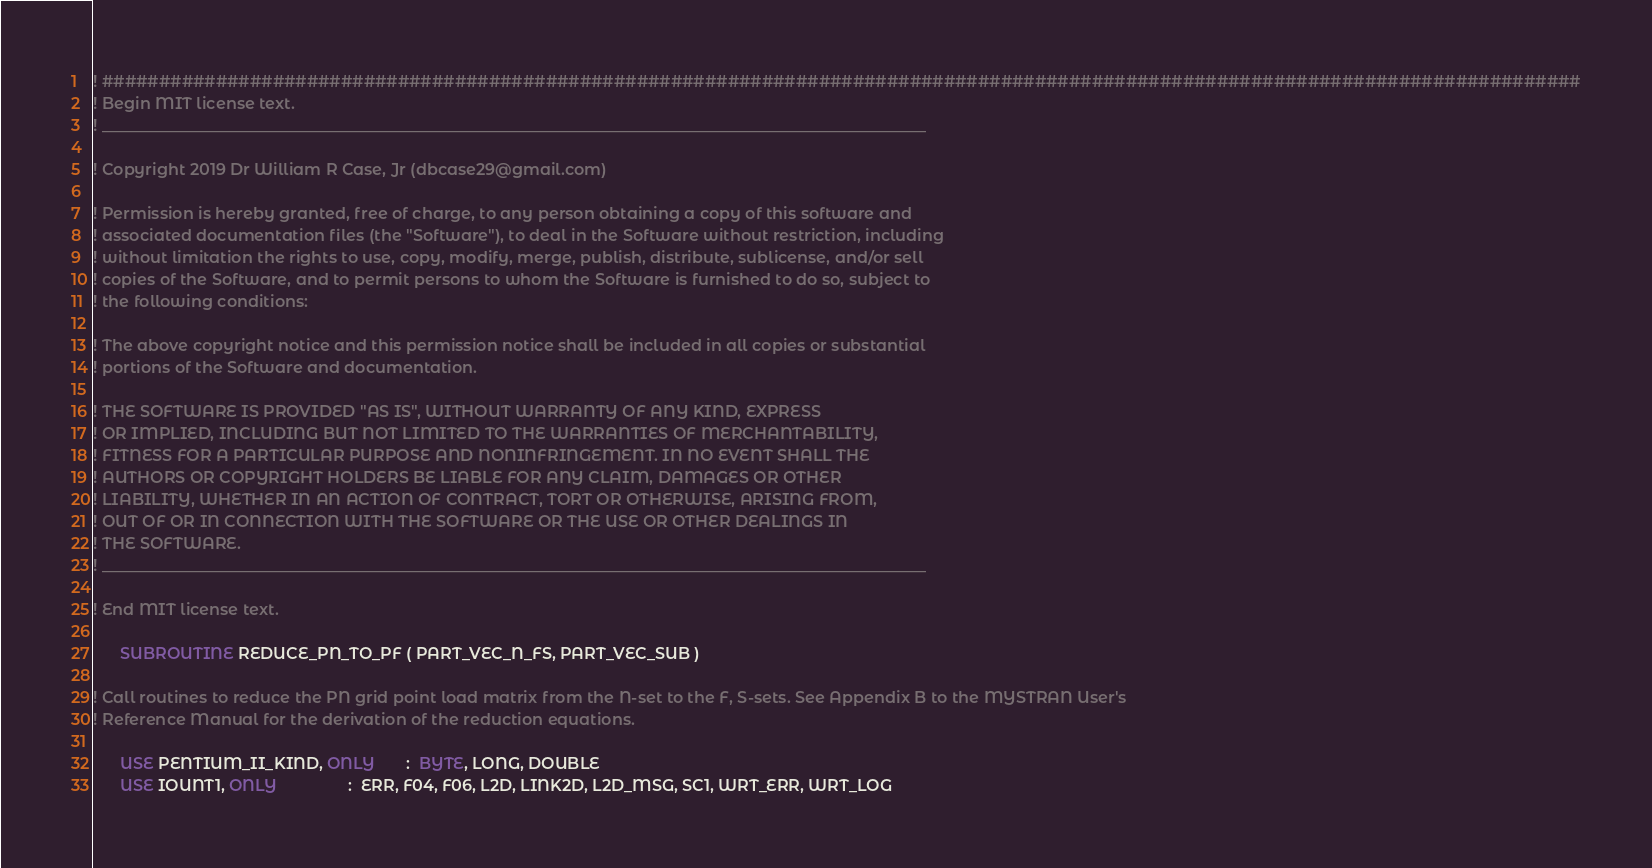Convert code to text. <code><loc_0><loc_0><loc_500><loc_500><_FORTRAN_>! ##################################################################################################################################
! Begin MIT license text.                                                                                    
! _______________________________________________________________________________________________________
                                                                                                         
! Copyright 2019 Dr William R Case, Jr (dbcase29@gmail.com)                                              
                                                                                                         
! Permission is hereby granted, free of charge, to any person obtaining a copy of this software and      
! associated documentation files (the "Software"), to deal in the Software without restriction, including
! without limitation the rights to use, copy, modify, merge, publish, distribute, sublicense, and/or sell
! copies of the Software, and to permit persons to whom the Software is furnished to do so, subject to   
! the following conditions:                                                                              
                                                                                                         
! The above copyright notice and this permission notice shall be included in all copies or substantial   
! portions of the Software and documentation.                                                                              
                                                                                                         
! THE SOFTWARE IS PROVIDED "AS IS", WITHOUT WARRANTY OF ANY KIND, EXPRESS                                
! OR IMPLIED, INCLUDING BUT NOT LIMITED TO THE WARRANTIES OF MERCHANTABILITY,                            
! FITNESS FOR A PARTICULAR PURPOSE AND NONINFRINGEMENT. IN NO EVENT SHALL THE                            
! AUTHORS OR COPYRIGHT HOLDERS BE LIABLE FOR ANY CLAIM, DAMAGES OR OTHER                                 
! LIABILITY, WHETHER IN AN ACTION OF CONTRACT, TORT OR OTHERWISE, ARISING FROM,                          
! OUT OF OR IN CONNECTION WITH THE SOFTWARE OR THE USE OR OTHER DEALINGS IN                              
! THE SOFTWARE.                                                                                          
! _______________________________________________________________________________________________________
                                                                                                        
! End MIT license text.                                                                                      

      SUBROUTINE REDUCE_PN_TO_PF ( PART_VEC_N_FS, PART_VEC_SUB )
 
! Call routines to reduce the PN grid point load matrix from the N-set to the F, S-sets. See Appendix B to the MYSTRAN User's
! Reference Manual for the derivation of the reduction equations.
 
      USE PENTIUM_II_KIND, ONLY       :  BYTE, LONG, DOUBLE
      USE IOUNT1, ONLY                :  ERR, F04, F06, L2D, LINK2D, L2D_MSG, SC1, WRT_ERR, WRT_LOG</code> 